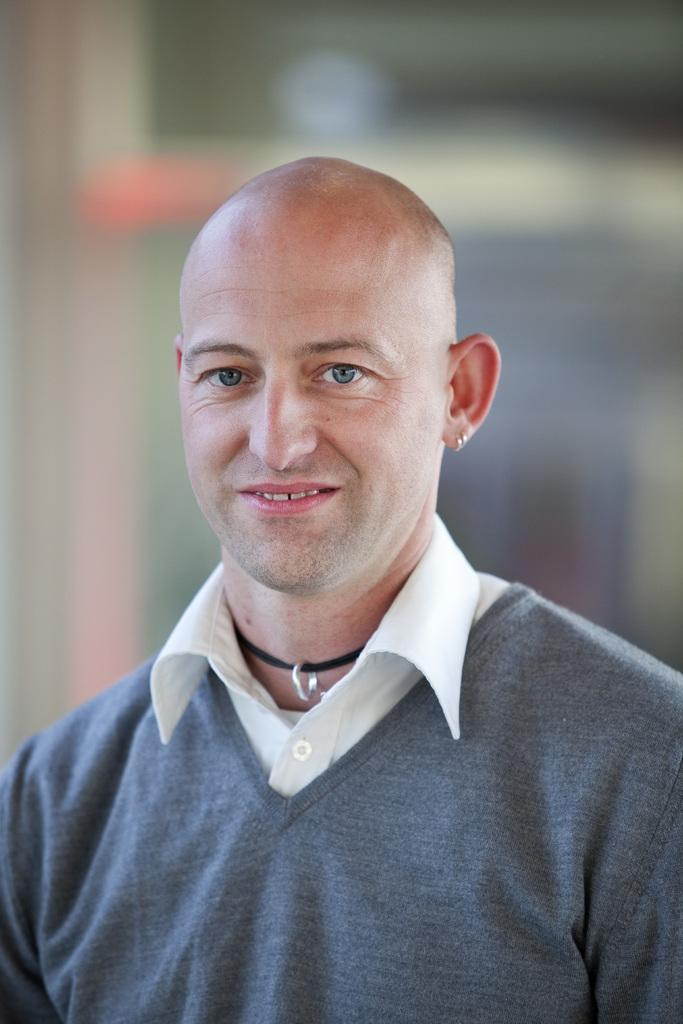What is the main subject of the image? There is a man in the image. What is the man's facial expression? The man is smiling. Can you describe the background of the image? The background of the image is blurred. How many cacti can be seen in the image? There are no cacti present in the image. What type of screw is being used by the man in the image? There is no screw visible in the image, as it features a man smiling with a blurred background. 